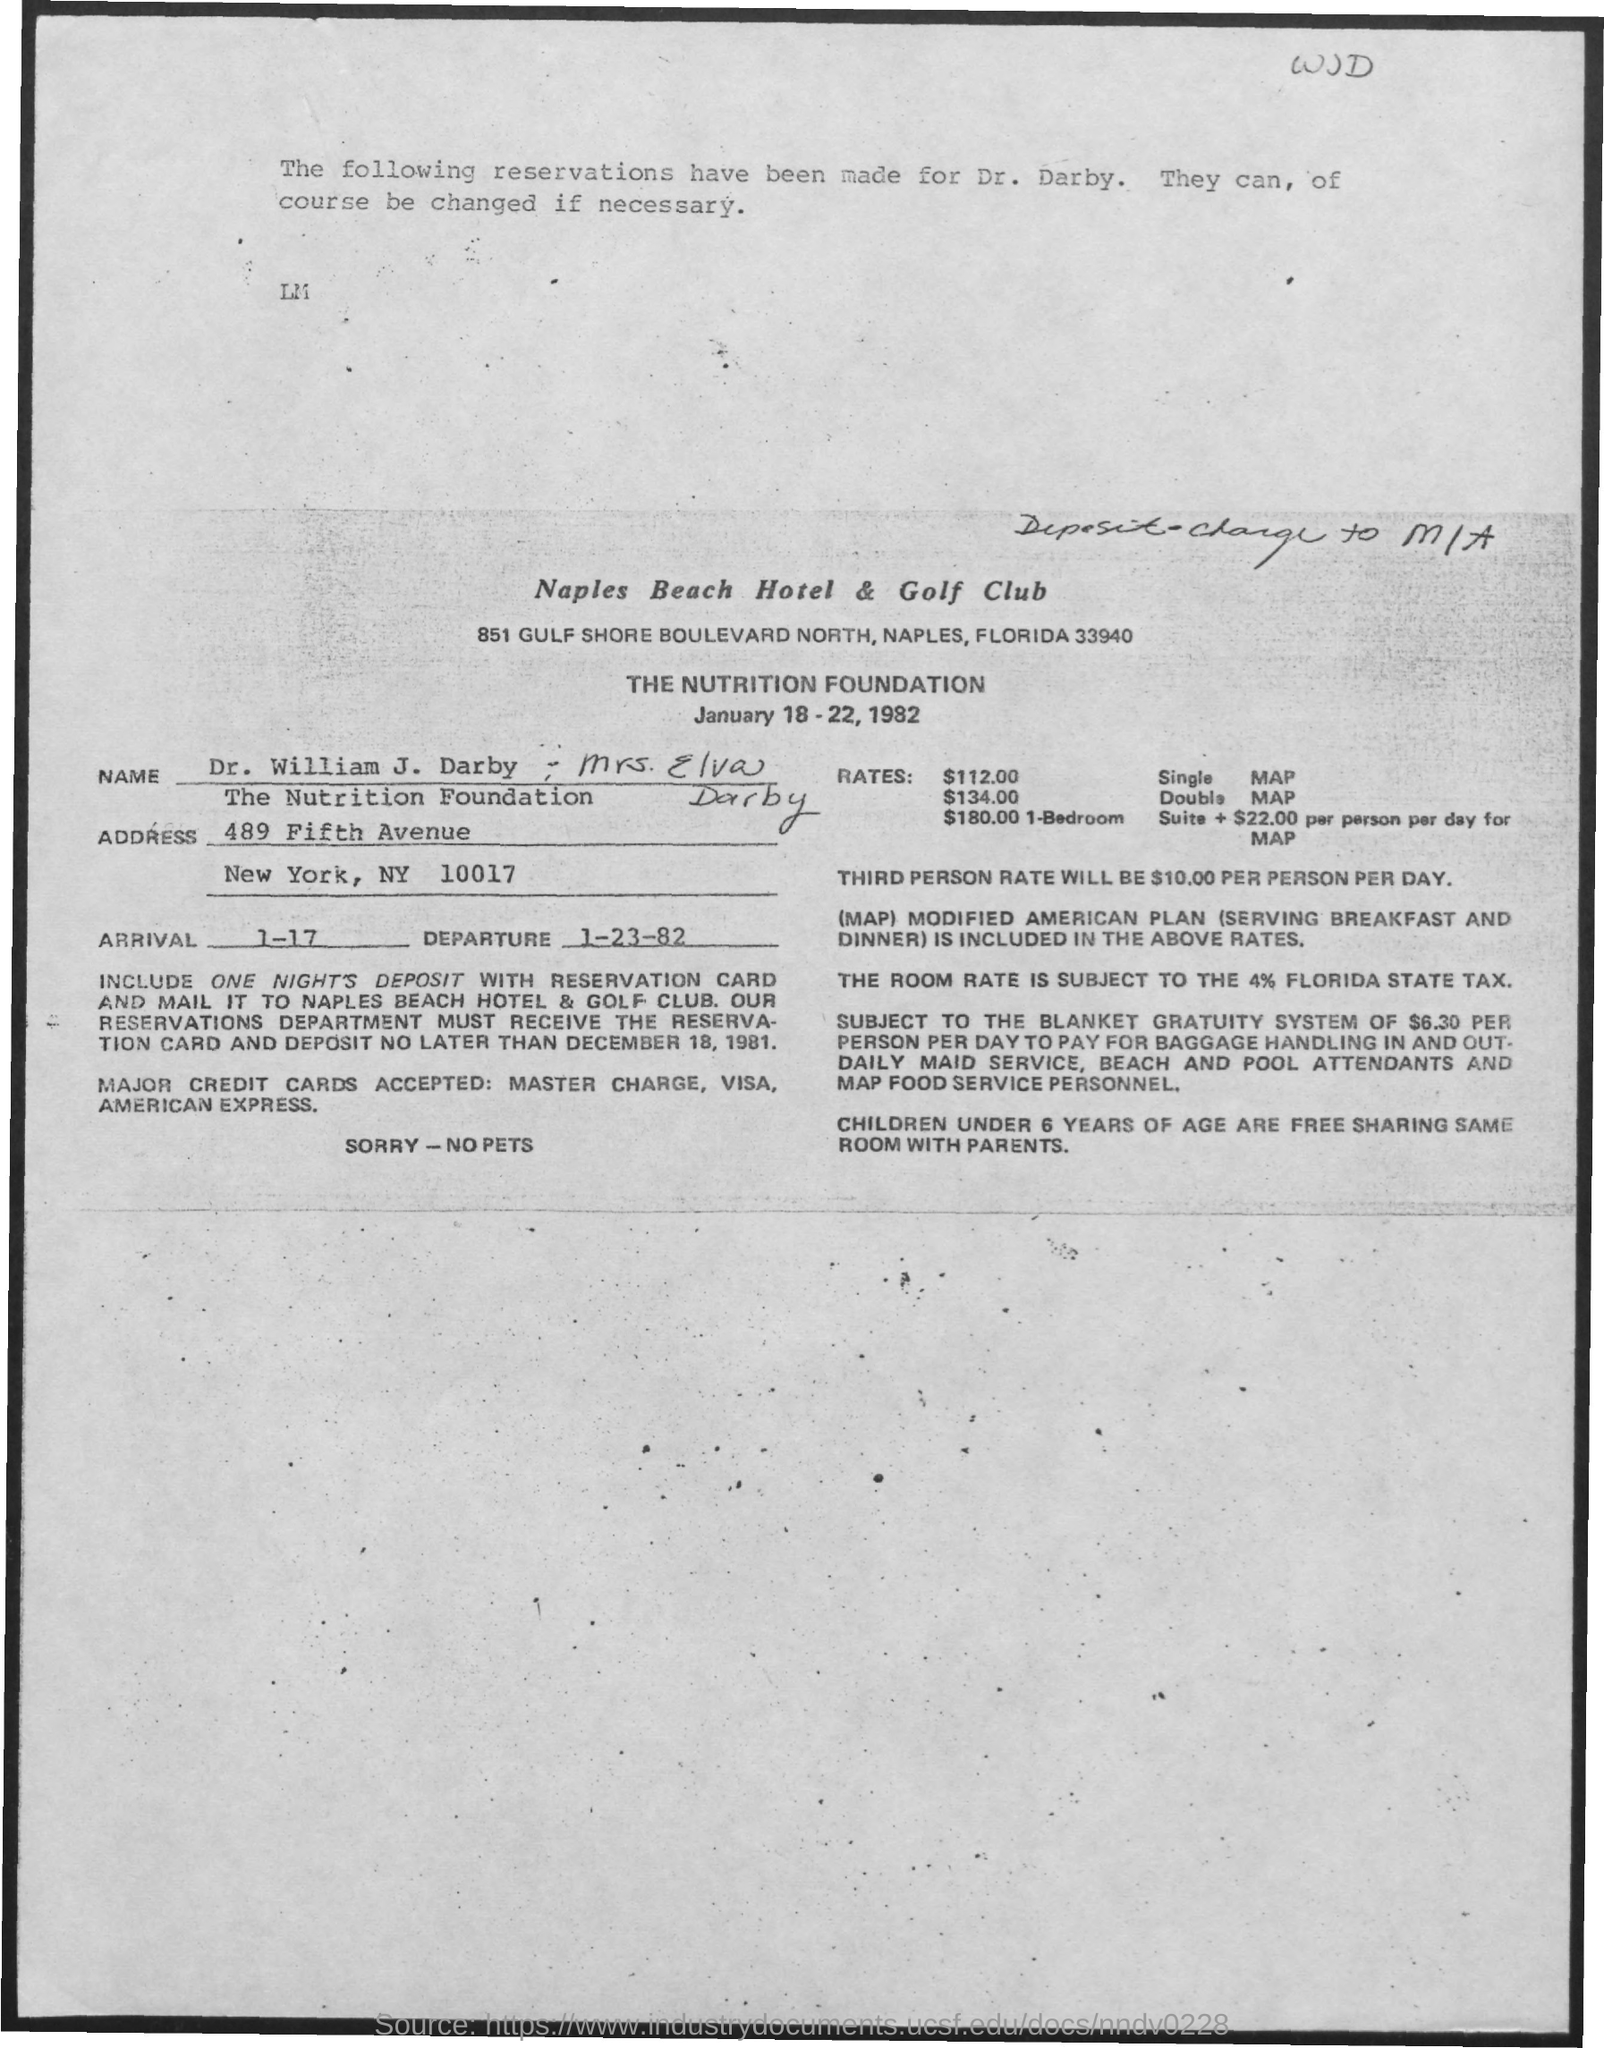What is the name of the Hotel where the reservation is done ?
Provide a short and direct response. Naples Beach Hotel & Golf Club. For whom is the reservation done?
Your response must be concise. Dr. William J. Darby , Mrs Elva Darby. 